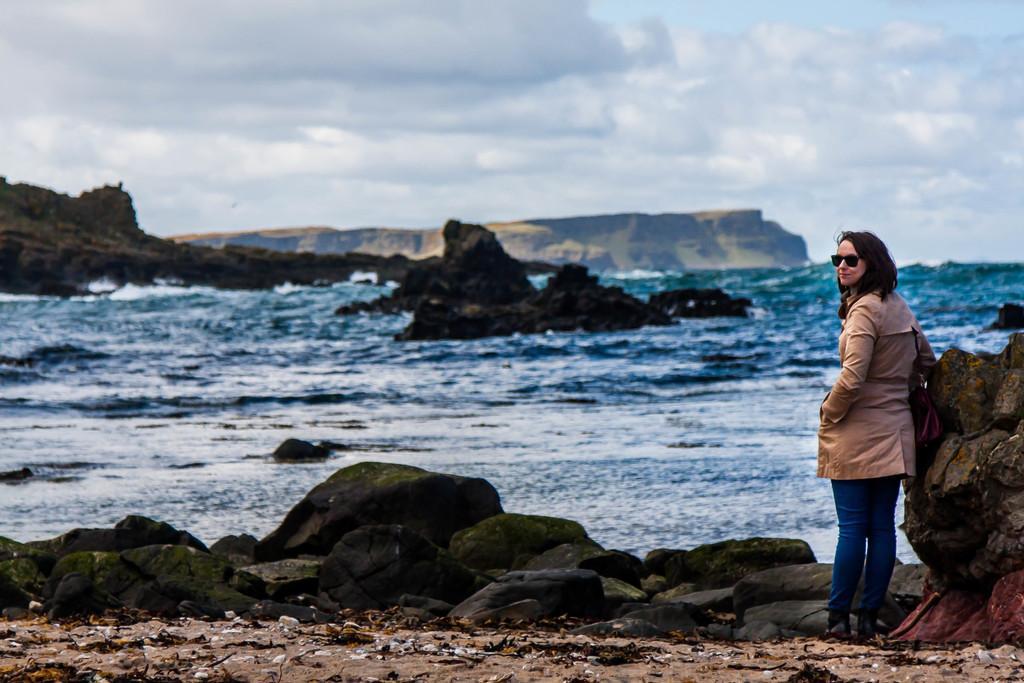Can you describe this image briefly? There is a lady standing on the right side of the image she is wearing sunglasses, there is a stone on the right side beside her. There are stones, water, it seems like a mountain and sky in the background area. 